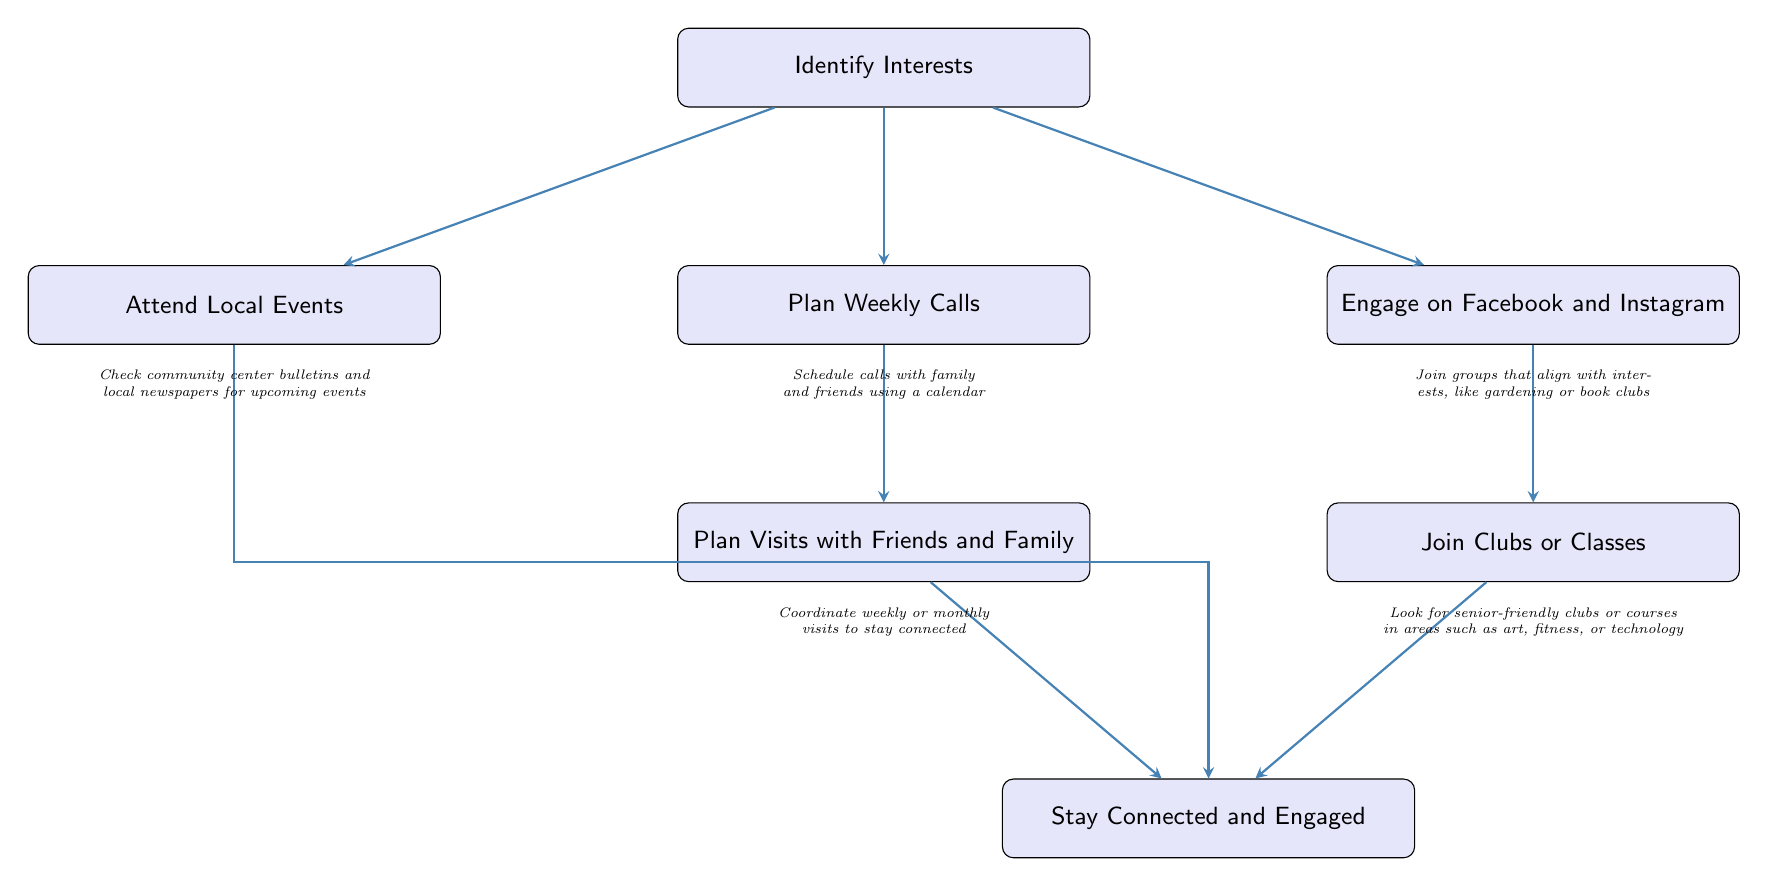What is the starting point of the diagram? The starting point of the diagram is labeled "Identify Interests". This is the first node that initiates the flow of actions described in the diagram.
Answer: Identify Interests How many main activities are listed after "Identify Interests"? There are five main activities listed in the diagram: Phone Calls, Social Media, Local Events, Visits with Friends and Family, and Clubs or Classes. This can be counted directly from the branches stemming from the starting point.
Answer: 5 What action is associated with "Visits with Friends and Family"? The action associated with "Visits with Friends and Family" is "Plan Visits with Friends and Family". This is found directly beneath the corresponding node in the diagram.
Answer: Plan Visits with Friends and Family Which two activities lead directly to the "Stay Connected and Engaged" node? The two activities that lead directly to the "Stay Connected and Engaged" node are "Visits with Friends and Family" and "Clubs or Classes". Both these nodes have arrows pointing directly to the conclusion node in the flow chart.
Answer: Visits with Friends and Family, Clubs or Classes What is a detailed step outlined for engaging on social media? A detailed step outlined for engaging on social media is "Join groups that align with interests, like gardening or book clubs". This is a recommendation provided directly under the "Social Media" action.
Answer: Join groups that align with interests, like gardening or book clubs What type of events should one check for under "Attend Local Events"? Under "Attend Local Events", one should check "community center bulletins and local newspapers for upcoming events." This specifies the sources to look for local activities.
Answer: Community center bulletins and local newspapers for upcoming events Which action directly follows "Plan Weekly Calls"? The action that directly follows "Plan Weekly Calls" is "Plan Visits with Friends and Family". This action follows the flow from the prior step in the diagram.
Answer: Plan Visits with Friends and Family 